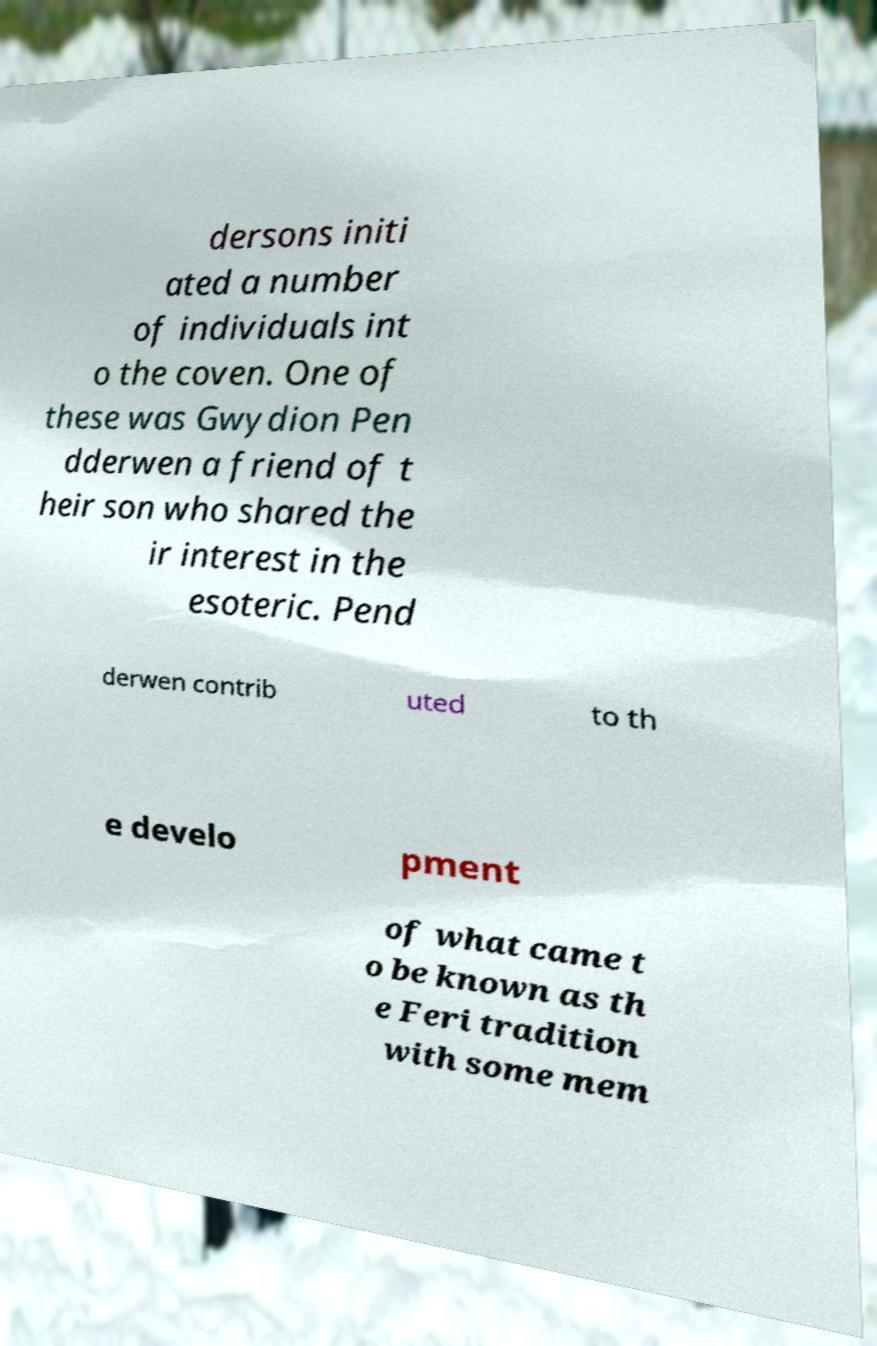Could you extract and type out the text from this image? dersons initi ated a number of individuals int o the coven. One of these was Gwydion Pen dderwen a friend of t heir son who shared the ir interest in the esoteric. Pend derwen contrib uted to th e develo pment of what came t o be known as th e Feri tradition with some mem 